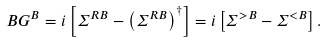<formula> <loc_0><loc_0><loc_500><loc_500>\ B G ^ { B } = i \left [ { \Sigma } ^ { R B } - \left ( { \Sigma } ^ { R B } \right ) ^ { \dagger } \right ] = i \left [ { \Sigma } ^ { > B } - { \Sigma } ^ { < B } \right ] .</formula> 